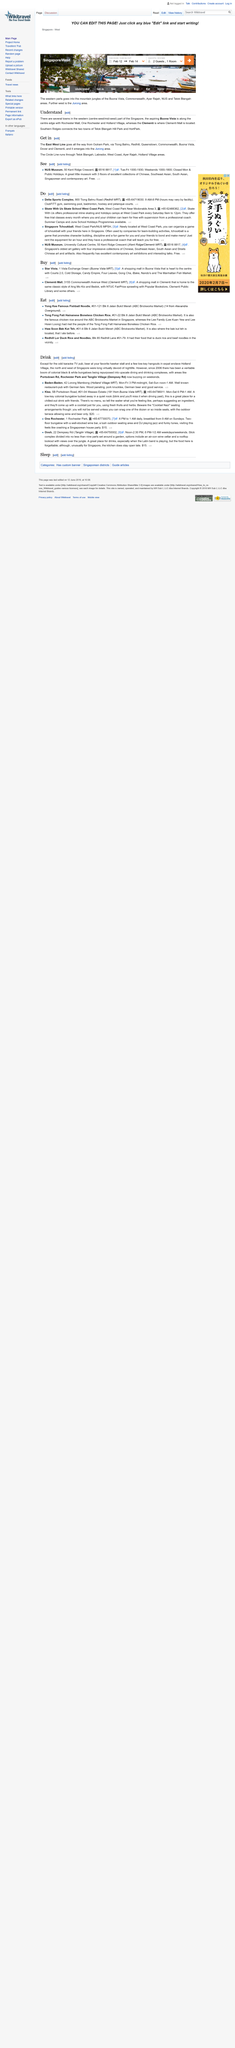Mention a couple of crucial points in this snapshot. Where can I have skate classes near West Coast Park? Skate With Us Skate School is located according to Do. The Delta Sports Complex number is a unique identifier that is +65-64719030. West Coast Park is located in the country of Singapore. 